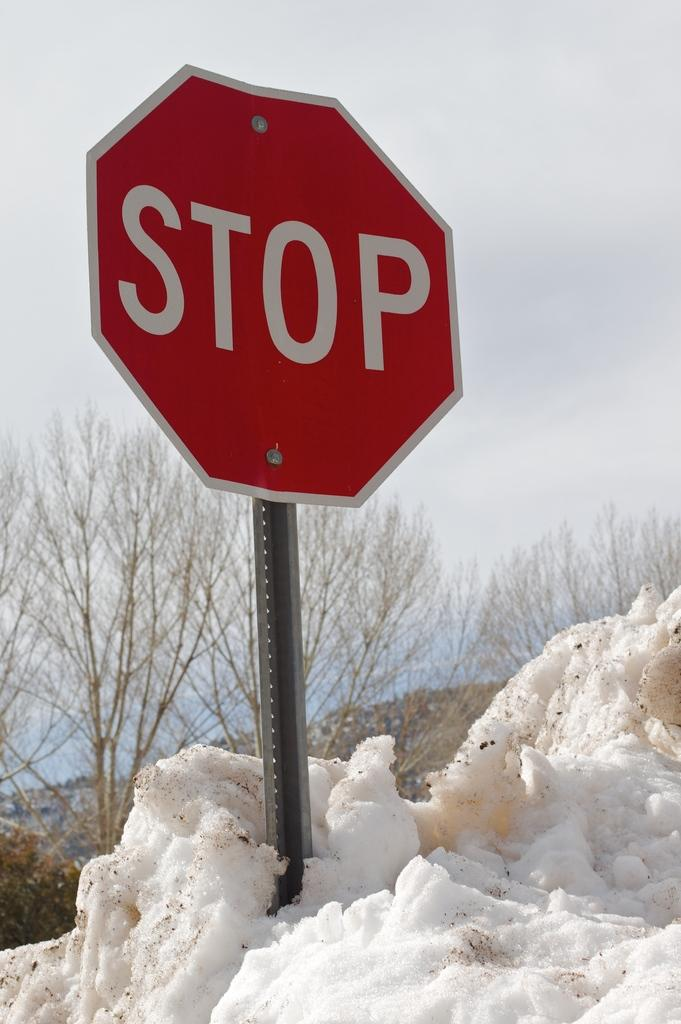<image>
Provide a brief description of the given image. A stop sign is piled around with snow. 